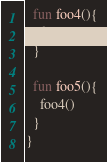Convert code to text. <code><loc_0><loc_0><loc_500><loc_500><_Kotlin_>  fun foo4(){
    foo3()
  }

  fun foo5(){
    foo4()
  }
}</code> 